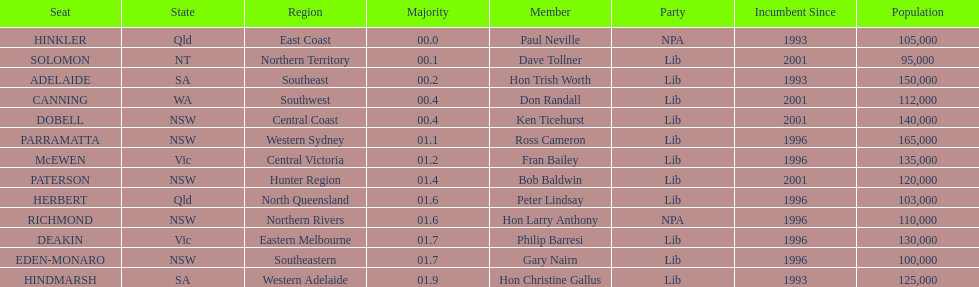I'm looking to parse the entire table for insights. Could you assist me with that? {'header': ['Seat', 'State', 'Region', 'Majority', 'Member', 'Party', 'Incumbent Since', 'Population'], 'rows': [['HINKLER', 'Qld', 'East Coast', '00.0', 'Paul Neville', 'NPA', '1993', '105,000'], ['SOLOMON', 'NT', 'Northern Territory', '00.1', 'Dave Tollner', 'Lib', '2001', '95,000'], ['ADELAIDE', 'SA', 'Southeast', '00.2', 'Hon Trish Worth', 'Lib', '1993', '150,000'], ['CANNING', 'WA', 'Southwest', '00.4', 'Don Randall', 'Lib', '2001', '112,000'], ['DOBELL', 'NSW', 'Central Coast', '00.4', 'Ken Ticehurst', 'Lib', '2001', '140,000'], ['PARRAMATTA', 'NSW', 'Western Sydney', '01.1', 'Ross Cameron', 'Lib', '1996', '165,000'], ['McEWEN', 'Vic', 'Central Victoria', '01.2', 'Fran Bailey', 'Lib', '1996', '135,000'], ['PATERSON', 'NSW', 'Hunter Region', '01.4', 'Bob Baldwin', 'Lib', '2001', '120,000'], ['HERBERT', 'Qld', 'North Queensland', '01.6', 'Peter Lindsay', 'Lib', '1996', '103,000'], ['RICHMOND', 'NSW', 'Northern Rivers', '01.6', 'Hon Larry Anthony', 'NPA', '1996', '110,000'], ['DEAKIN', 'Vic', 'Eastern Melbourne', '01.7', 'Philip Barresi', 'Lib', '1996', '130,000'], ['EDEN-MONARO', 'NSW', 'Southeastern', '01.7', 'Gary Nairn', 'Lib', '1996', '100,000'], ['HINDMARSH', 'SA', 'Western Adelaide', '01.9', 'Hon Christine Gallus', 'Lib', '1993', '125,000']]} Was fran bailey from vic or wa? Vic. 